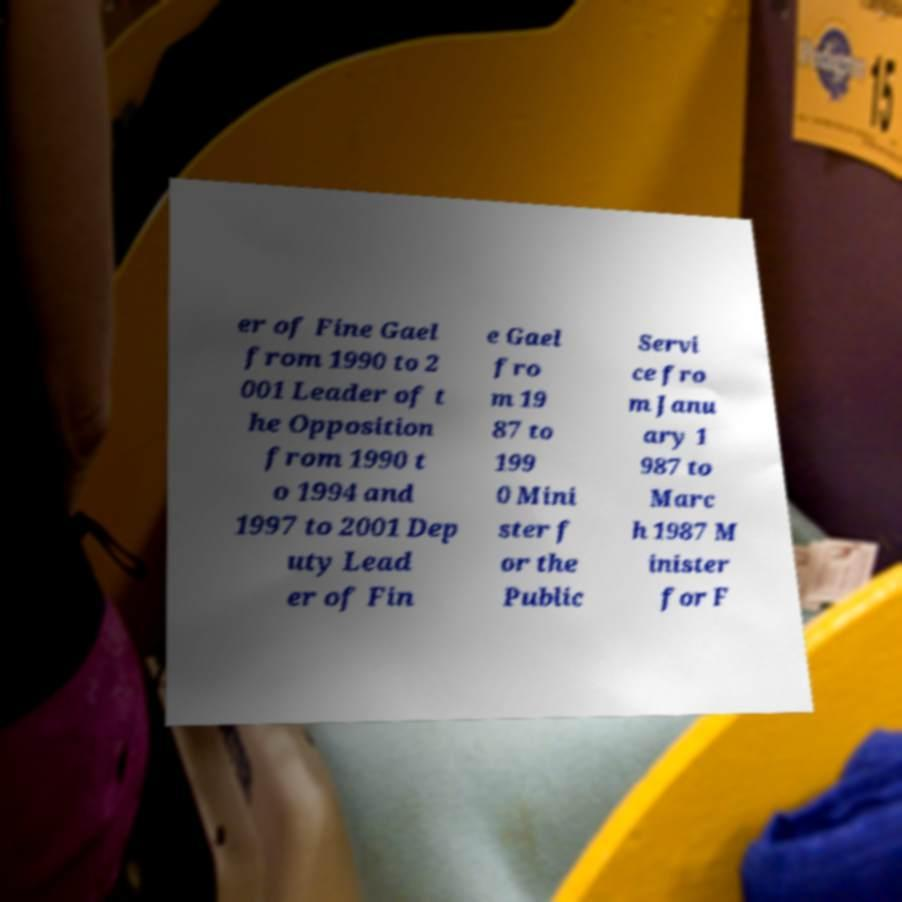There's text embedded in this image that I need extracted. Can you transcribe it verbatim? er of Fine Gael from 1990 to 2 001 Leader of t he Opposition from 1990 t o 1994 and 1997 to 2001 Dep uty Lead er of Fin e Gael fro m 19 87 to 199 0 Mini ster f or the Public Servi ce fro m Janu ary 1 987 to Marc h 1987 M inister for F 